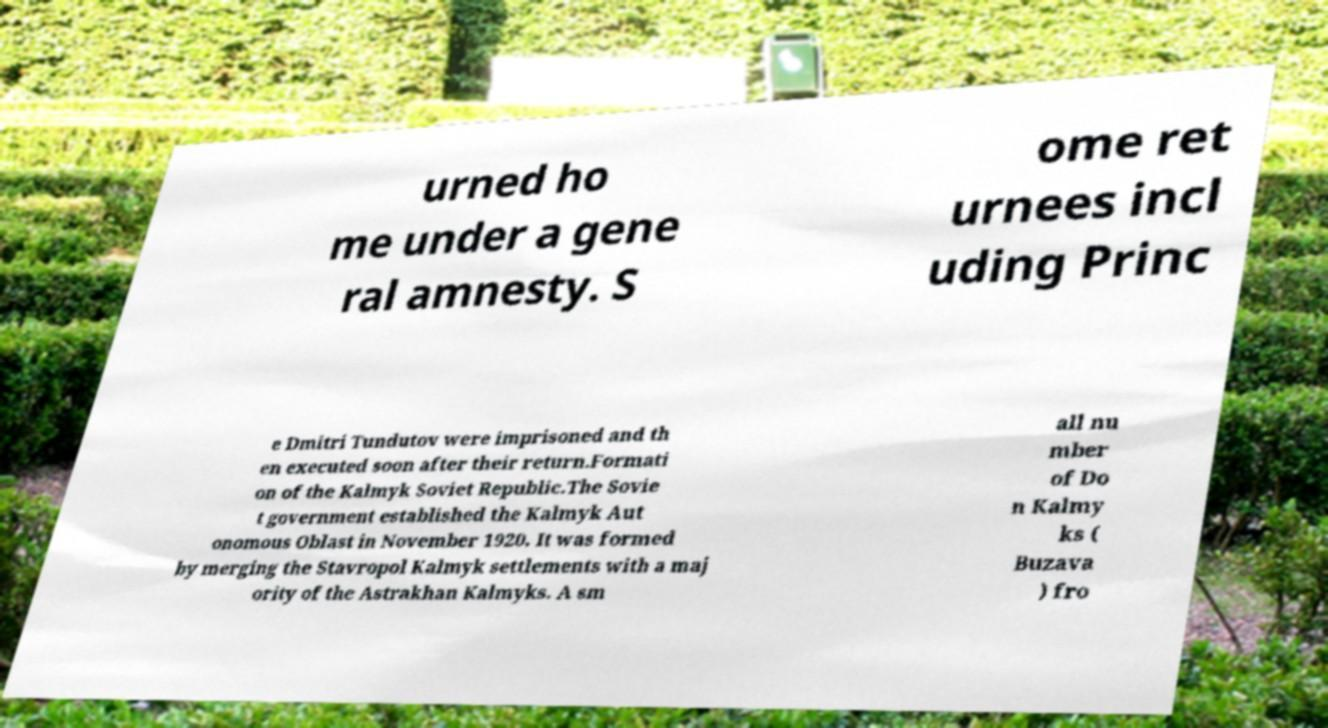Please identify and transcribe the text found in this image. urned ho me under a gene ral amnesty. S ome ret urnees incl uding Princ e Dmitri Tundutov were imprisoned and th en executed soon after their return.Formati on of the Kalmyk Soviet Republic.The Sovie t government established the Kalmyk Aut onomous Oblast in November 1920. It was formed by merging the Stavropol Kalmyk settlements with a maj ority of the Astrakhan Kalmyks. A sm all nu mber of Do n Kalmy ks ( Buzava ) fro 